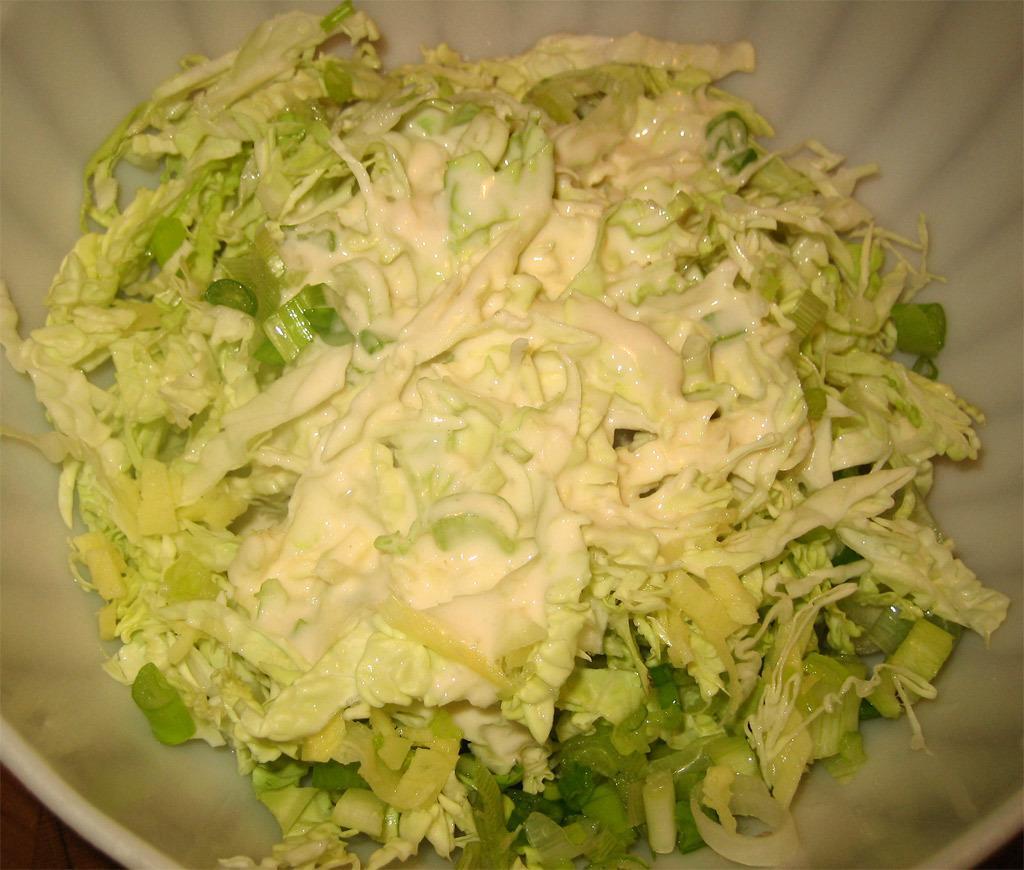Could you give a brief overview of what you see in this image? In this image we can see some food in a bowl which is placed on the surface. 